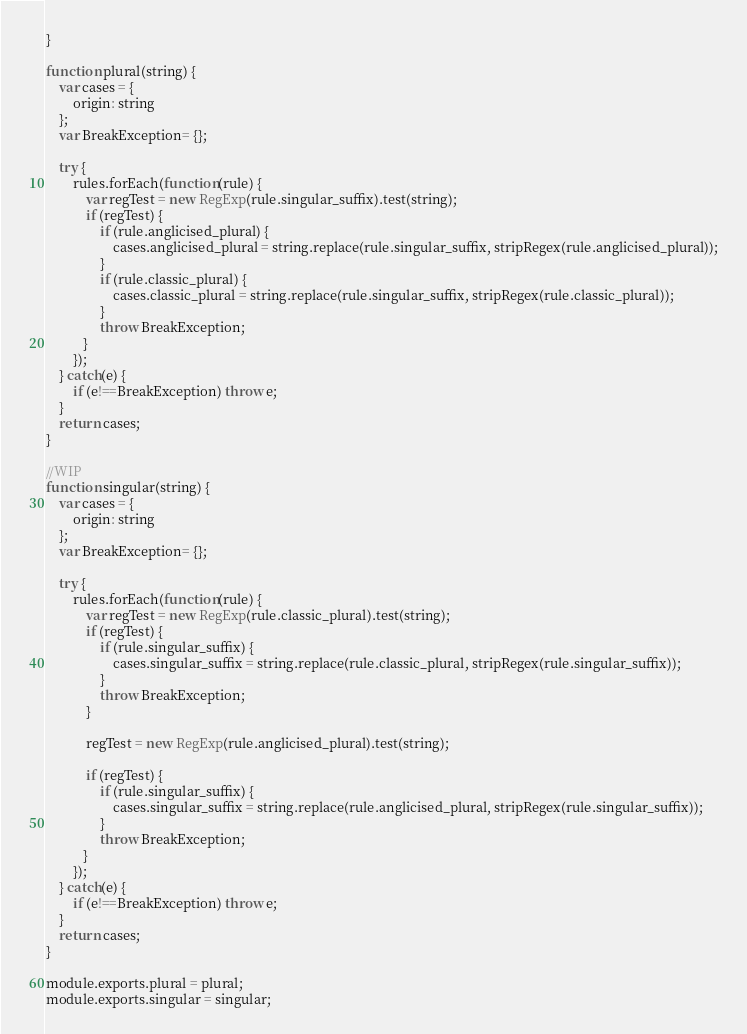Convert code to text. <code><loc_0><loc_0><loc_500><loc_500><_JavaScript_>}

function plural(string) {
    var cases = {
        origin: string
    };
    var BreakException= {};

    try {
        rules.forEach(function(rule) {
            var regTest = new RegExp(rule.singular_suffix).test(string);
            if (regTest) {
                if (rule.anglicised_plural) {
                    cases.anglicised_plural = string.replace(rule.singular_suffix, stripRegex(rule.anglicised_plural));
                }
                if (rule.classic_plural) {
                    cases.classic_plural = string.replace(rule.singular_suffix, stripRegex(rule.classic_plural));
                }
                throw BreakException;
           }
        });
    } catch(e) {
        if (e!==BreakException) throw e;
    }
    return cases;
}

//WIP
function singular(string) {
    var cases = {
        origin: string
    };
    var BreakException= {};

    try {
        rules.forEach(function(rule) {
            var regTest = new RegExp(rule.classic_plural).test(string);
            if (regTest) {
                if (rule.singular_suffix) {
                    cases.singular_suffix = string.replace(rule.classic_plural, stripRegex(rule.singular_suffix));
                }
                throw BreakException;
            }
            
            regTest = new RegExp(rule.anglicised_plural).test(string);
            
            if (regTest) {
                if (rule.singular_suffix) {
                    cases.singular_suffix = string.replace(rule.anglicised_plural, stripRegex(rule.singular_suffix));
                }
                throw BreakException;
           }
        });
    } catch(e) {
        if (e!==BreakException) throw e;
    }
    return cases;
}

module.exports.plural = plural;
module.exports.singular = singular;</code> 